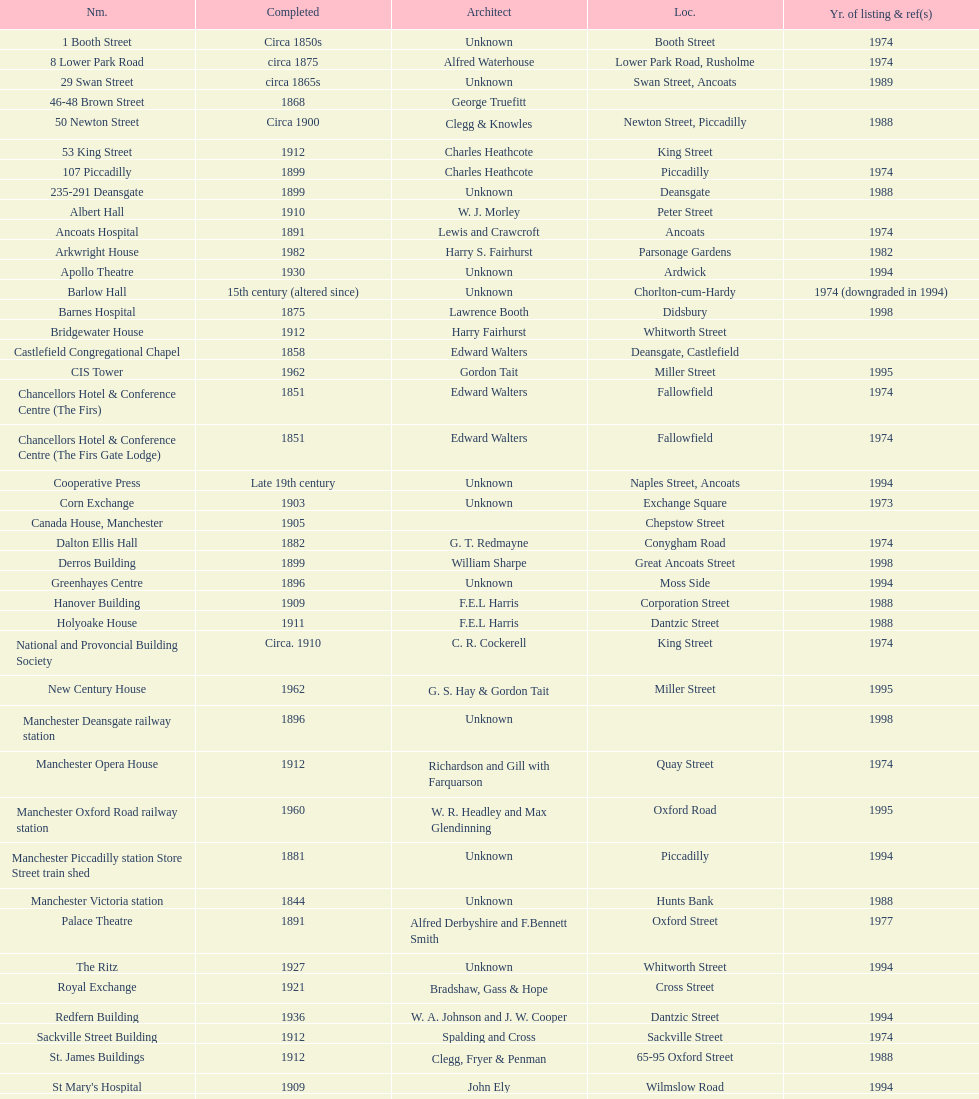Give me the full table as a dictionary. {'header': ['Nm.', 'Completed', 'Architect', 'Loc.', 'Yr. of listing & ref(s)'], 'rows': [['1 Booth Street', 'Circa 1850s', 'Unknown', 'Booth Street', '1974'], ['8 Lower Park Road', 'circa 1875', 'Alfred Waterhouse', 'Lower Park Road, Rusholme', '1974'], ['29 Swan Street', 'circa 1865s', 'Unknown', 'Swan Street, Ancoats', '1989'], ['46-48 Brown Street', '1868', 'George Truefitt', '', ''], ['50 Newton Street', 'Circa 1900', 'Clegg & Knowles', 'Newton Street, Piccadilly', '1988'], ['53 King Street', '1912', 'Charles Heathcote', 'King Street', ''], ['107 Piccadilly', '1899', 'Charles Heathcote', 'Piccadilly', '1974'], ['235-291 Deansgate', '1899', 'Unknown', 'Deansgate', '1988'], ['Albert Hall', '1910', 'W. J. Morley', 'Peter Street', ''], ['Ancoats Hospital', '1891', 'Lewis and Crawcroft', 'Ancoats', '1974'], ['Arkwright House', '1982', 'Harry S. Fairhurst', 'Parsonage Gardens', '1982'], ['Apollo Theatre', '1930', 'Unknown', 'Ardwick', '1994'], ['Barlow Hall', '15th century (altered since)', 'Unknown', 'Chorlton-cum-Hardy', '1974 (downgraded in 1994)'], ['Barnes Hospital', '1875', 'Lawrence Booth', 'Didsbury', '1998'], ['Bridgewater House', '1912', 'Harry Fairhurst', 'Whitworth Street', ''], ['Castlefield Congregational Chapel', '1858', 'Edward Walters', 'Deansgate, Castlefield', ''], ['CIS Tower', '1962', 'Gordon Tait', 'Miller Street', '1995'], ['Chancellors Hotel & Conference Centre (The Firs)', '1851', 'Edward Walters', 'Fallowfield', '1974'], ['Chancellors Hotel & Conference Centre (The Firs Gate Lodge)', '1851', 'Edward Walters', 'Fallowfield', '1974'], ['Cooperative Press', 'Late 19th century', 'Unknown', 'Naples Street, Ancoats', '1994'], ['Corn Exchange', '1903', 'Unknown', 'Exchange Square', '1973'], ['Canada House, Manchester', '1905', '', 'Chepstow Street', ''], ['Dalton Ellis Hall', '1882', 'G. T. Redmayne', 'Conygham Road', '1974'], ['Derros Building', '1899', 'William Sharpe', 'Great Ancoats Street', '1998'], ['Greenhayes Centre', '1896', 'Unknown', 'Moss Side', '1994'], ['Hanover Building', '1909', 'F.E.L Harris', 'Corporation Street', '1988'], ['Holyoake House', '1911', 'F.E.L Harris', 'Dantzic Street', '1988'], ['National and Provoncial Building Society', 'Circa. 1910', 'C. R. Cockerell', 'King Street', '1974'], ['New Century House', '1962', 'G. S. Hay & Gordon Tait', 'Miller Street', '1995'], ['Manchester Deansgate railway station', '1896', 'Unknown', '', '1998'], ['Manchester Opera House', '1912', 'Richardson and Gill with Farquarson', 'Quay Street', '1974'], ['Manchester Oxford Road railway station', '1960', 'W. R. Headley and Max Glendinning', 'Oxford Road', '1995'], ['Manchester Piccadilly station Store Street train shed', '1881', 'Unknown', 'Piccadilly', '1994'], ['Manchester Victoria station', '1844', 'Unknown', 'Hunts Bank', '1988'], ['Palace Theatre', '1891', 'Alfred Derbyshire and F.Bennett Smith', 'Oxford Street', '1977'], ['The Ritz', '1927', 'Unknown', 'Whitworth Street', '1994'], ['Royal Exchange', '1921', 'Bradshaw, Gass & Hope', 'Cross Street', ''], ['Redfern Building', '1936', 'W. A. Johnson and J. W. Cooper', 'Dantzic Street', '1994'], ['Sackville Street Building', '1912', 'Spalding and Cross', 'Sackville Street', '1974'], ['St. James Buildings', '1912', 'Clegg, Fryer & Penman', '65-95 Oxford Street', '1988'], ["St Mary's Hospital", '1909', 'John Ely', 'Wilmslow Road', '1994'], ['Samuel Alexander Building', '1919', 'Percy Scott Worthington', 'Oxford Road', '2010'], ['Ship Canal House', '1927', 'Harry S. Fairhurst', 'King Street', '1982'], ['Smithfield Market Hall', '1857', 'Unknown', 'Swan Street, Ancoats', '1973'], ['Strangeways Gaol Gatehouse', '1868', 'Alfred Waterhouse', 'Sherborne Street', '1974'], ['Strangeways Prison ventilation and watch tower', '1868', 'Alfred Waterhouse', 'Sherborne Street', '1974'], ['Theatre Royal', '1845', 'Irwin and Chester', 'Peter Street', '1974'], ['Toast Rack', '1960', 'L. C. Howitt', 'Fallowfield', '1999'], ['The Old Wellington Inn', 'Mid-16th century', 'Unknown', 'Shambles Square', '1952'], ['Whitworth Park Mansions', 'Circa 1840s', 'Unknown', 'Whitworth Park', '1974']]} How many names are listed with an image? 39. 